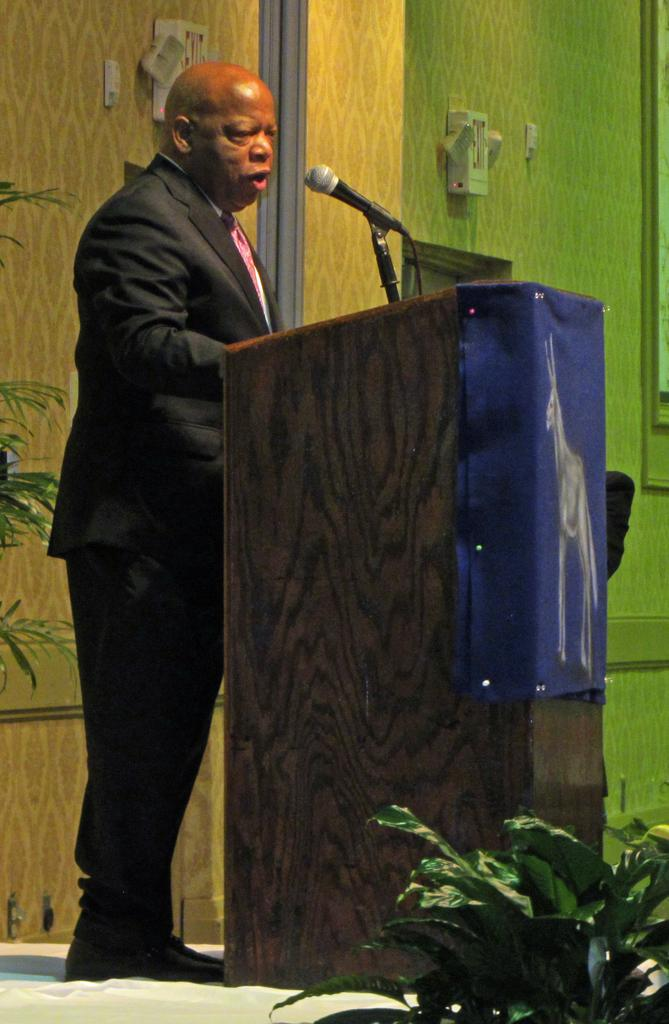What is the man in the image doing? The man is standing at the podium in the image. What is attached to the podium? A microphone is attached to the podium. What can be seen in the background of the image? Walls and houseplants are visible in the background of the image. What type of bike is the man riding in the image? There is no bike present in the image; the man is standing at a podium. What type of throne is the man sitting on in the image? There is no throne present in the image; the man is standing at a podium. 